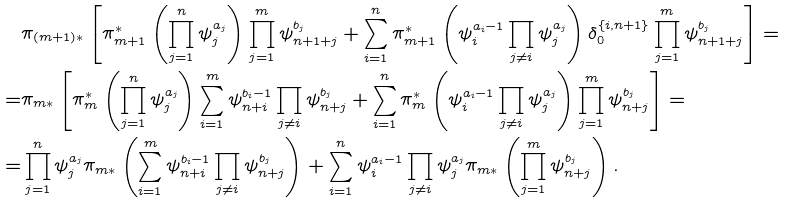<formula> <loc_0><loc_0><loc_500><loc_500>& \pi _ { ( m + 1 ) * } \left [ \pi _ { m + 1 } ^ { * } \left ( \prod _ { j = 1 } ^ { n } \psi _ { j } ^ { a _ { j } } \right ) \prod _ { j = 1 } ^ { m } \psi _ { n + 1 + j } ^ { b _ { j } } + \sum _ { i = 1 } ^ { n } \pi _ { m + 1 } ^ { * } \left ( \psi _ { i } ^ { a _ { i } - 1 } \prod _ { j \ne i } \psi _ { j } ^ { a _ { j } } \right ) \delta _ { 0 } ^ { \{ i , n + 1 \} } \prod _ { j = 1 } ^ { m } \psi _ { n + 1 + j } ^ { b _ { j } } \right ] = \\ = & \pi _ { m * } \left [ \pi _ { m } ^ { * } \left ( \prod _ { j = 1 } ^ { n } \psi _ { j } ^ { a _ { j } } \right ) \sum _ { i = 1 } ^ { m } \psi _ { n + i } ^ { b _ { i } - 1 } \prod _ { j \ne i } \psi _ { n + j } ^ { b _ { j } } + \sum _ { i = 1 } ^ { n } \pi _ { m } ^ { * } \left ( \psi _ { i } ^ { a _ { i } - 1 } \prod _ { j \ne i } \psi _ { j } ^ { a _ { j } } \right ) \prod _ { j = 1 } ^ { m } \psi _ { n + j } ^ { b _ { j } } \right ] = \\ = & \prod _ { j = 1 } ^ { n } \psi _ { j } ^ { a _ { j } } \pi _ { m * } \left ( \sum _ { i = 1 } ^ { m } \psi _ { n + i } ^ { b _ { i } - 1 } \prod _ { j \ne i } \psi _ { n + j } ^ { b _ { j } } \right ) + \sum _ { i = 1 } ^ { n } \psi _ { i } ^ { a _ { i } - 1 } \prod _ { j \ne i } \psi _ { j } ^ { a _ { j } } \pi _ { m * } \left ( \prod _ { j = 1 } ^ { m } \psi _ { n + j } ^ { b _ { j } } \right ) .</formula> 